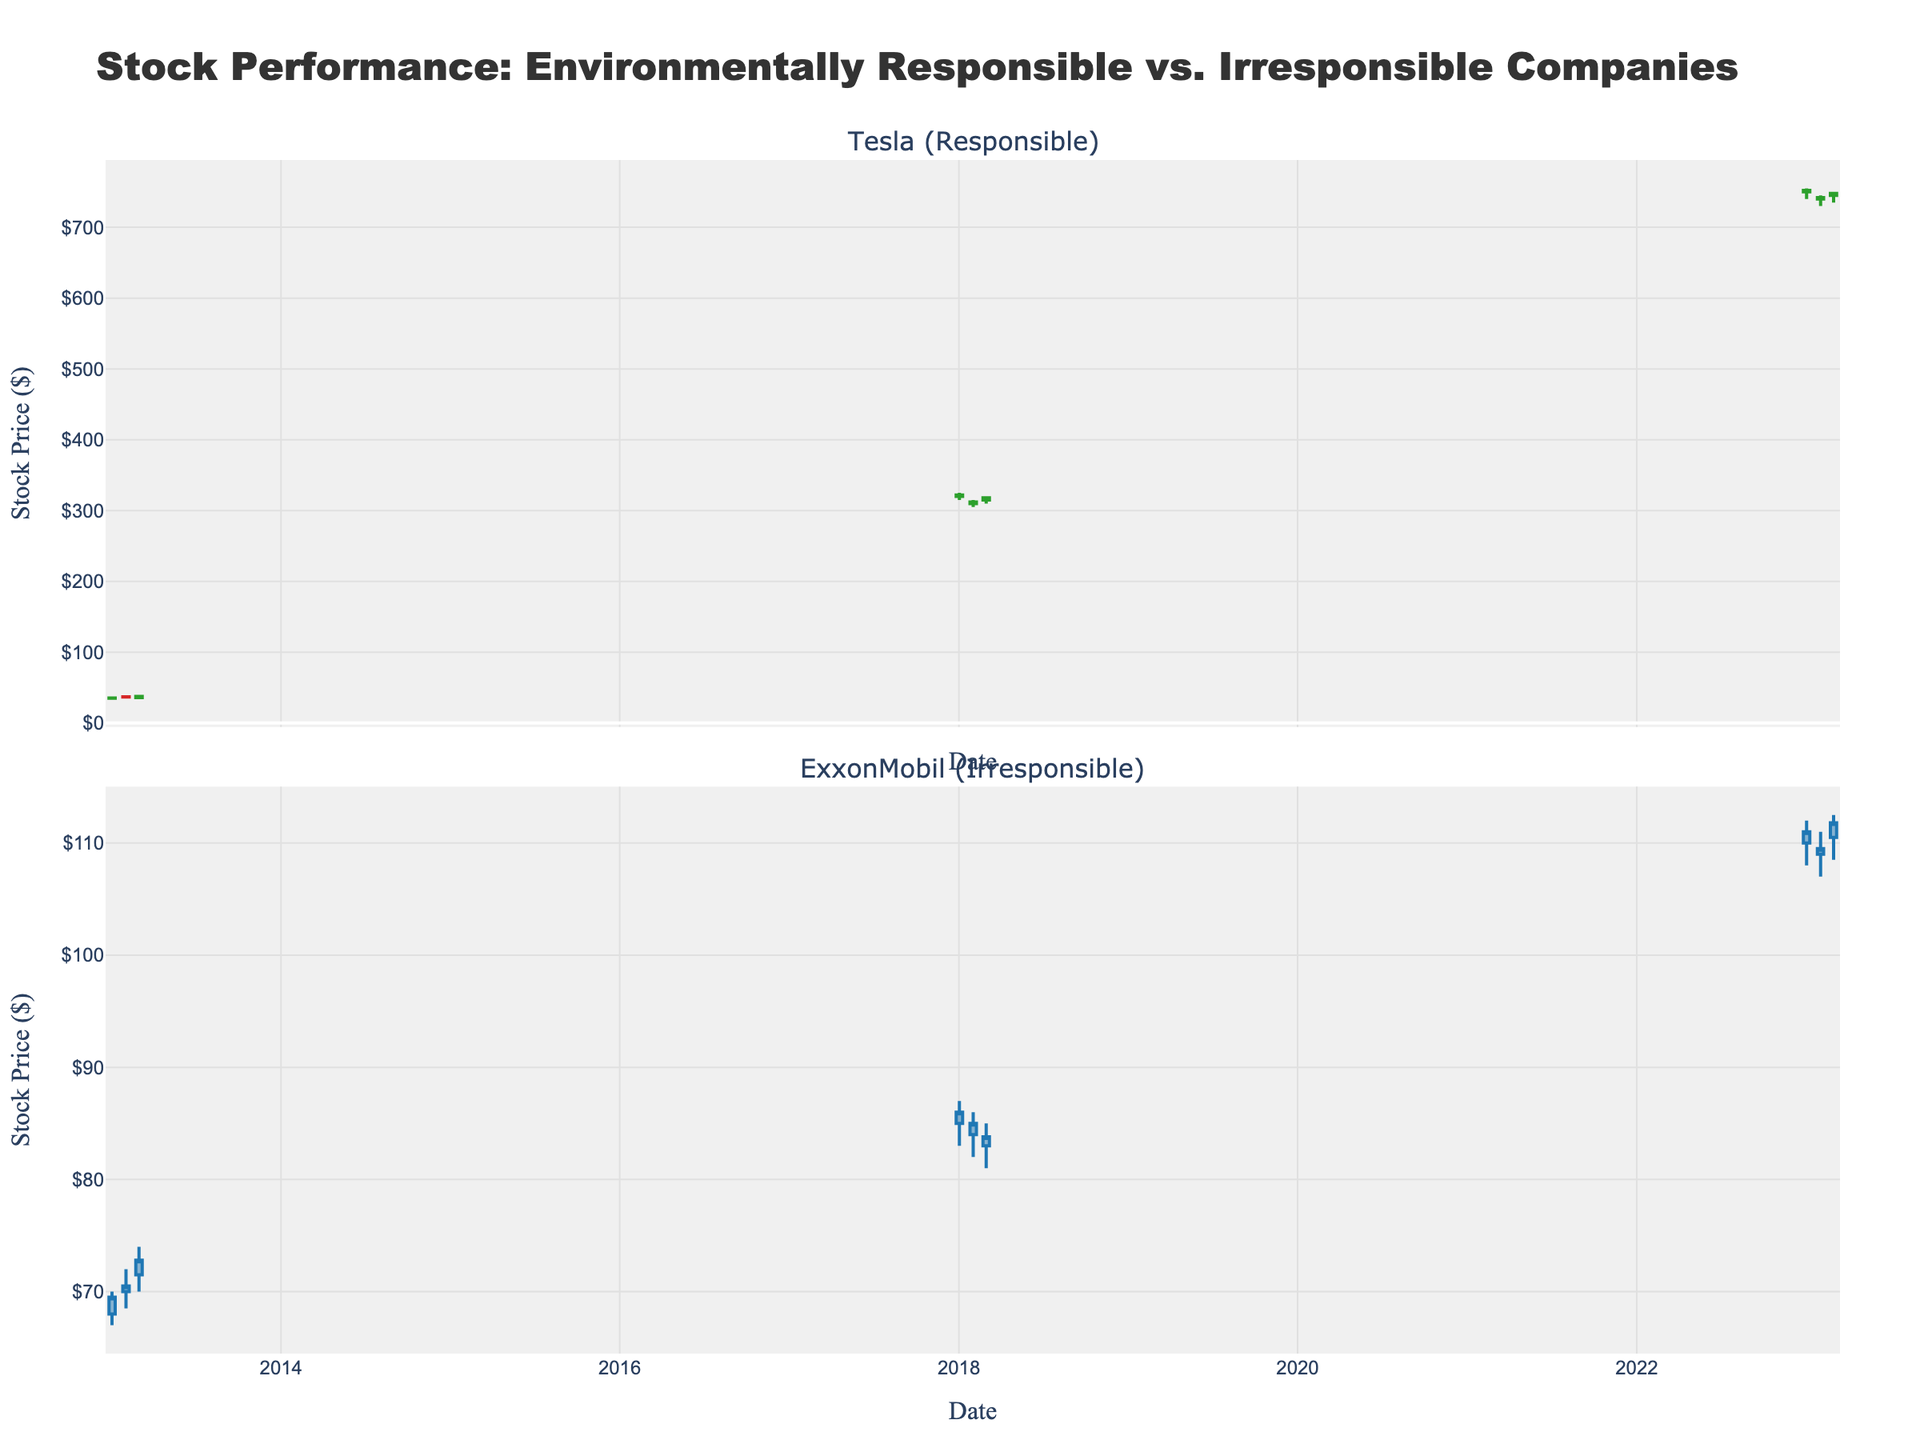What is the title of the plot? The title is usually displayed at the top of the plot and is often the most prominent text. Here, it reads 'Stock Performance: Environmentally Responsible vs. Irresponsible Companies'.
Answer: Stock Performance: Environmentally Responsible vs. Irresponsible Companies What color represents Tesla's increasing stock prices? In a candlestick plot, increasing stock prices are represented by specific colors. For Tesla, the increasing line color is indicated as '#2ca02c', which is green.
Answer: Green Between 2013 and 2023, which company's stock increased more significantly? By observing the starting and ending values of the candlestick charts for both Tesla and ExxonMobil, Tesla's stock went from about $35 to around $750, while ExxonMobil's stock moved from about $68 to around $110.
Answer: Tesla Compare the stock performance of Tesla and ExxonMobil in January 2018. Which company had higher volatility? Volatility can be assessed by the range between the high and low prices in January 2018. For Tesla, the range is $325 - $315 = $10. For ExxonMobil, the range is $87 - $83 = $4.
Answer: Tesla What is the closing price of ExxonMobil's stock in February 2023? The closing price for ExxonMobil in February 2023 is identified from the candlestick plot details.
Answer: $109.50 Between 2018 and 2023, did Tesla's stock ever go below $300? By evaluating the low prices shown in the candlestick chart for Tesla from 2018 to 2023, all prices are above $300.
Answer: No What is the average closing price of Tesla's stock in 2018? To find the average, sum the closing prices for the given months in 2018 and divide by the number of months: (322 + 312 + 318)/3.
Answer: $317.33 Did ExxonMobil's stock price ever drop below $80 in 2018? The candlestick plot for ExxonMobil in 2018 shows that the lowest price did not drop below $80.
Answer: No 